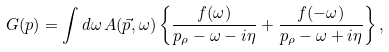Convert formula to latex. <formula><loc_0><loc_0><loc_500><loc_500>G ( p ) = \int d \omega \, A ( \vec { p } , \omega ) \left \{ \frac { f ( \omega ) } { p _ { \rho } - \omega - i \eta } + \frac { f ( - \omega ) } { p _ { \rho } - \omega + i \eta } \right \} ,</formula> 